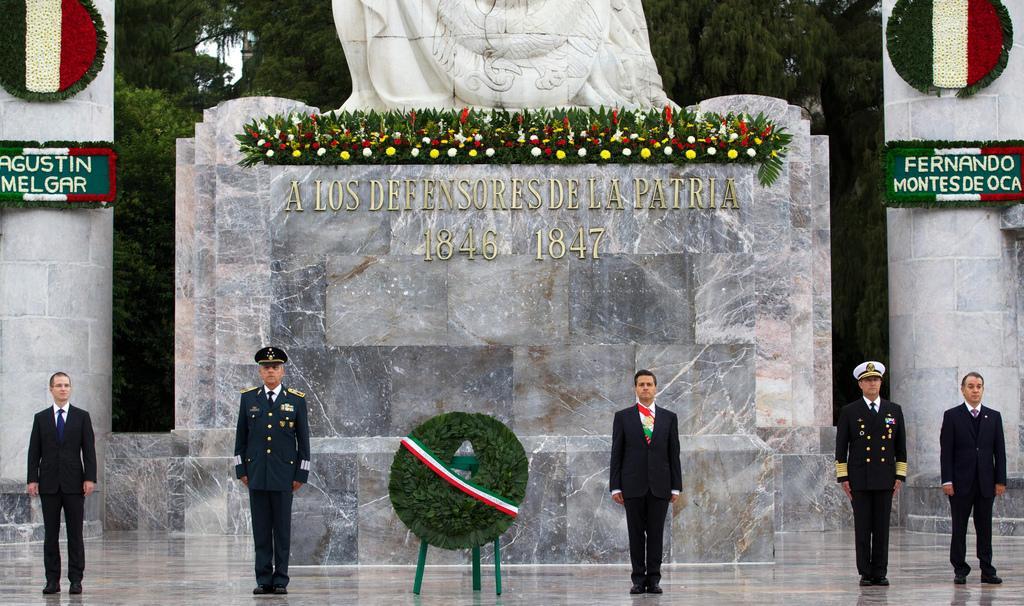Please provide a concise description of this image. In this picture I can see 5 men standing in front, where 3 men are wearing formal dress and other 2 men are wearing uniform and in the middle of this picture I can see a garland. In the background I can see 2 pillars and a marble thing and I see few flowers and leaves on the marble thing and I see something is written and I can also see something is written on the pillars and I can see few trees. 